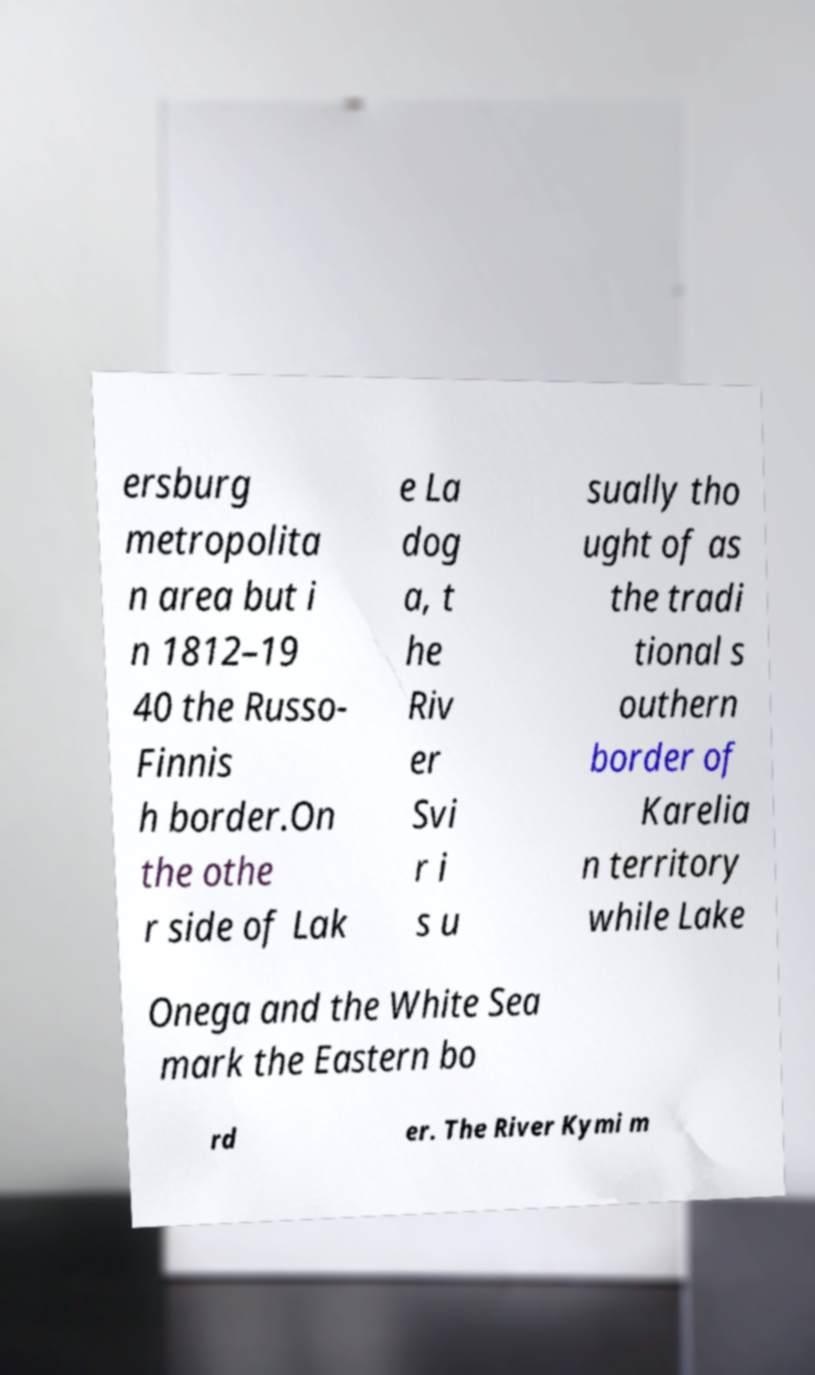What messages or text are displayed in this image? I need them in a readable, typed format. ersburg metropolita n area but i n 1812–19 40 the Russo- Finnis h border.On the othe r side of Lak e La dog a, t he Riv er Svi r i s u sually tho ught of as the tradi tional s outhern border of Karelia n territory while Lake Onega and the White Sea mark the Eastern bo rd er. The River Kymi m 